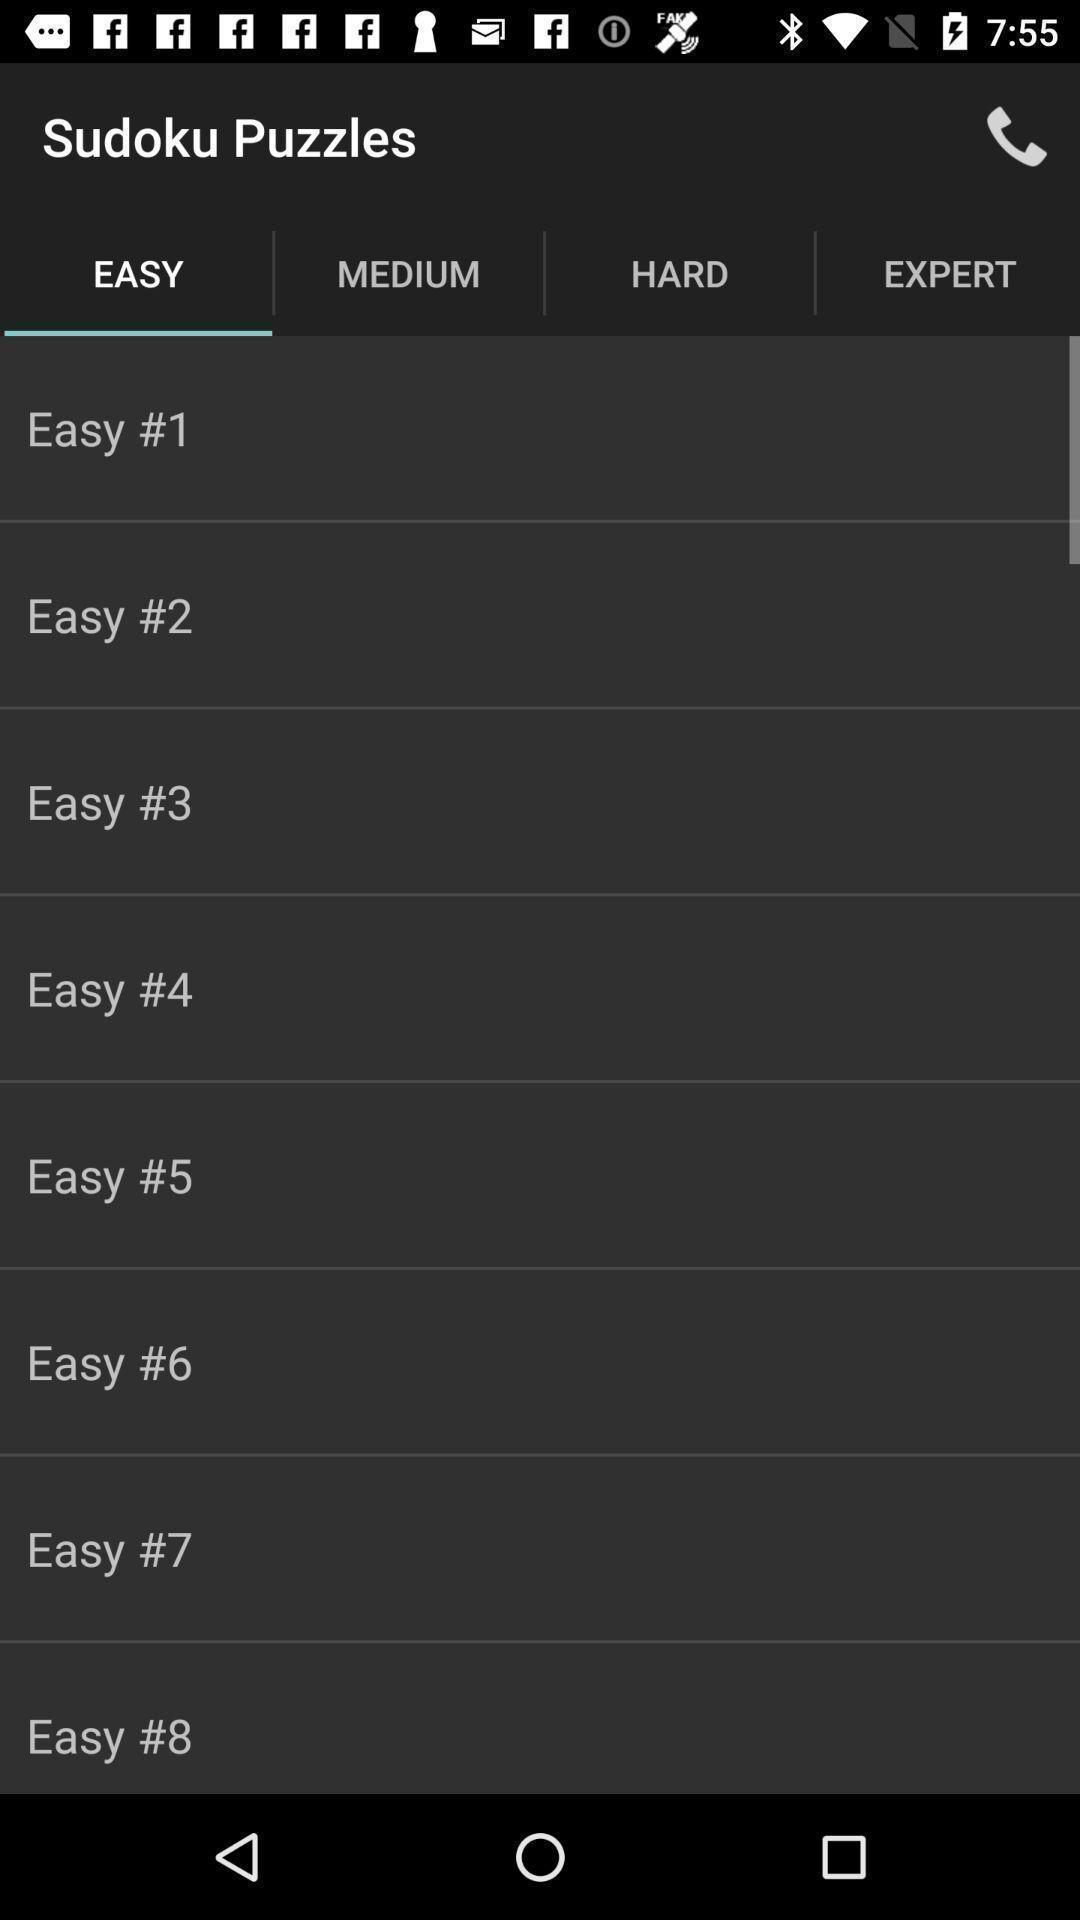Describe the visual elements of this screenshot. Sudoku puzzles levels. 